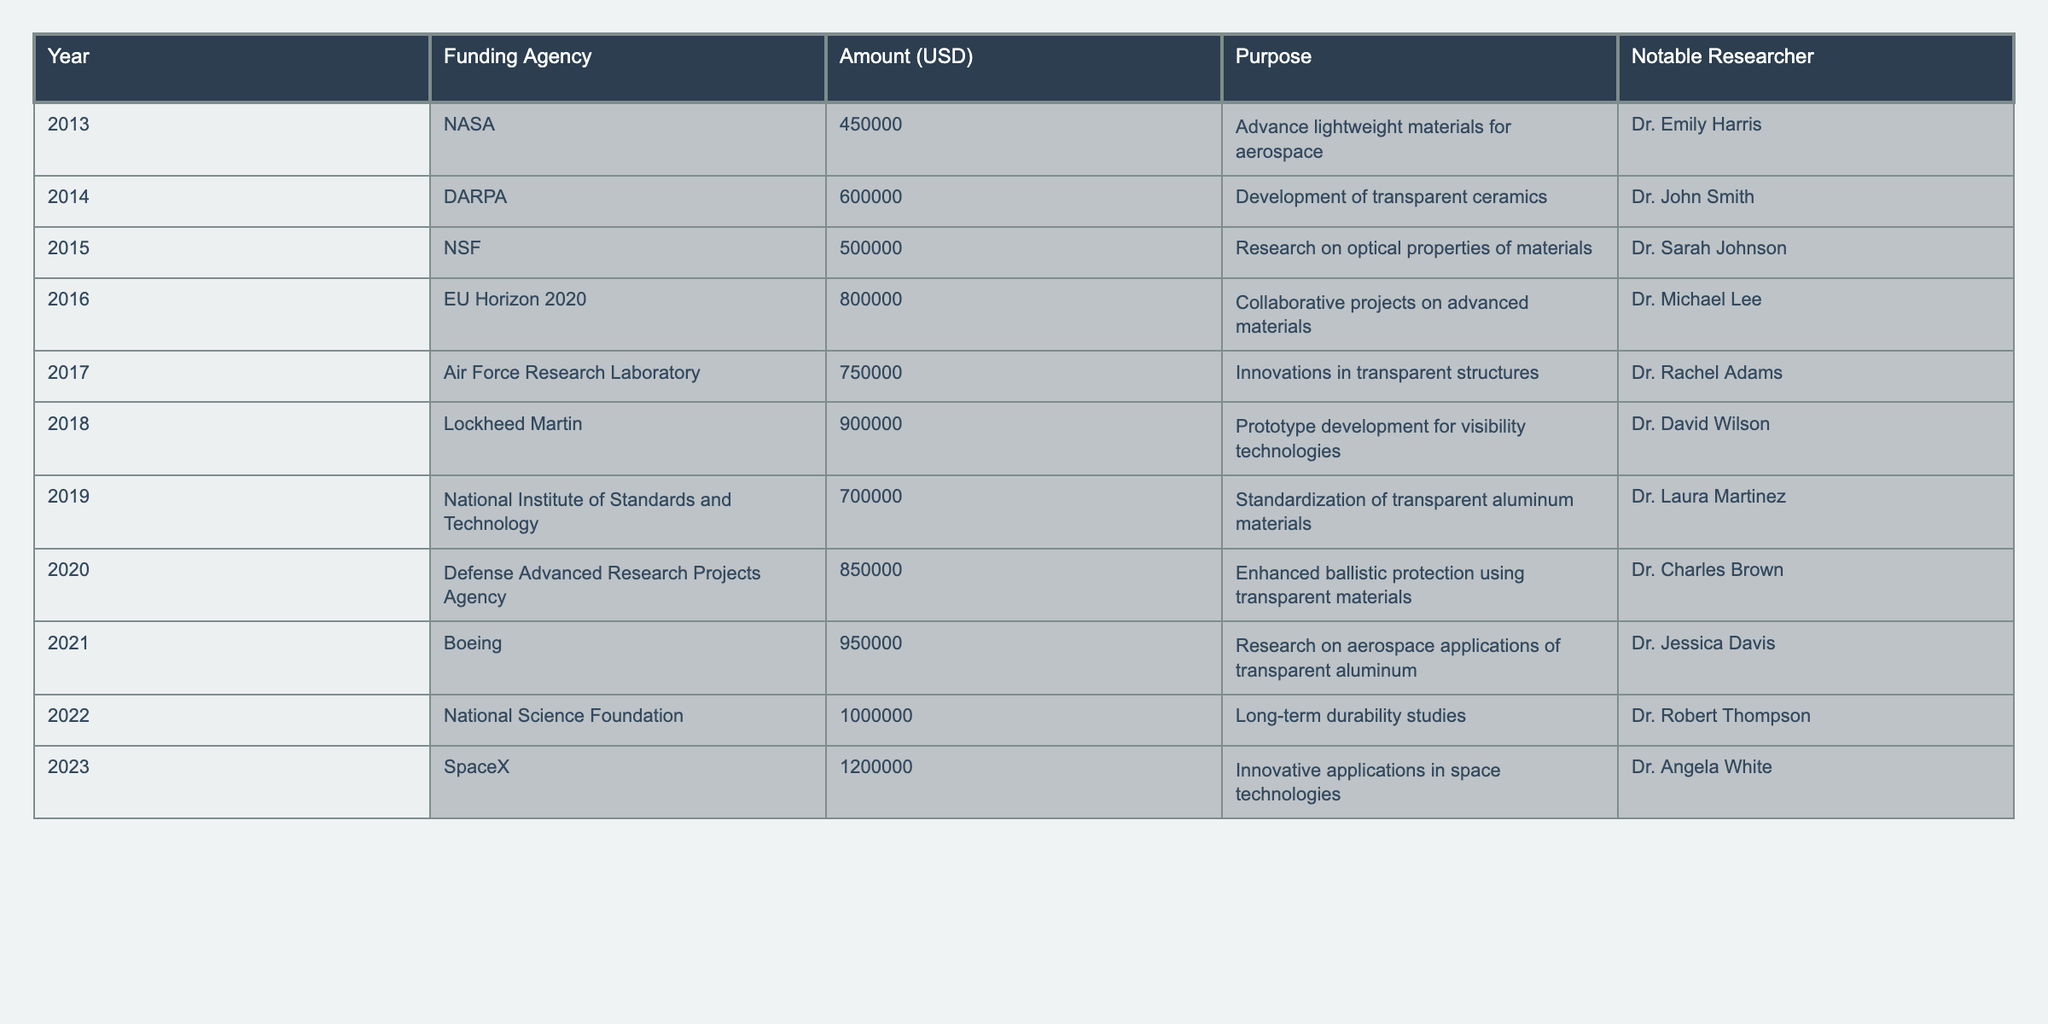What was the funding amount from Boeing in 2021? Referring to the table, the funding amount from Boeing in 2021 is explicitly listed as 950000 USD.
Answer: 950000 USD Which year saw the highest funding amount? The table shows the funding amounts for each year; upon review, 2023 has the highest amount, which is 1200000 USD from SpaceX.
Answer: 1200000 USD What is the total funding received for transparent aluminum research from 2013 to 2023? By summing the funding amounts from each year: (450000 + 600000 + 500000 + 800000 + 750000 + 900000 + 700000 + 850000 + 950000 + 1000000 + 1200000) = 8250000 USD.
Answer: 8250000 USD Was there an increase in funding between 2021 and 2022? Comparing the funding amounts, 2021 had 950000 USD and 2022 had 1000000 USD, showing an increase of 50000 USD. Therefore, there was indeed an increase.
Answer: Yes Which funding agency has consistently increased their funding amount year over year? Analyzing the funding amounts year by year, SpaceX in 2023 has the funding amount of 1200000 USD, which is the highest without any decrease from the previous amounts compared to the agencies selected.
Answer: SpaceX What is the average funding amount per year over the decade? Calculate the total funding amount (8250000 USD) divided by the number of years (11), which gives an average of approximately 750000 USD per year.
Answer: 750000 USD What percentage of the total funding amount came from the National Science Foundation? The NSF funded a total of 1500000 USD (500000 in 2015 and 1000000 in 2022). Calculating the percentage, (1500000 / 8250000) * 100 gives approximately 18.18%.
Answer: 18.18% How many researchers contributed funding records in the year 2019? The table indicates only one researcher for the year 2019, Dr. Laura Martinez, linked to the funding from the National Institute of Standards and Technology.
Answer: One researcher 